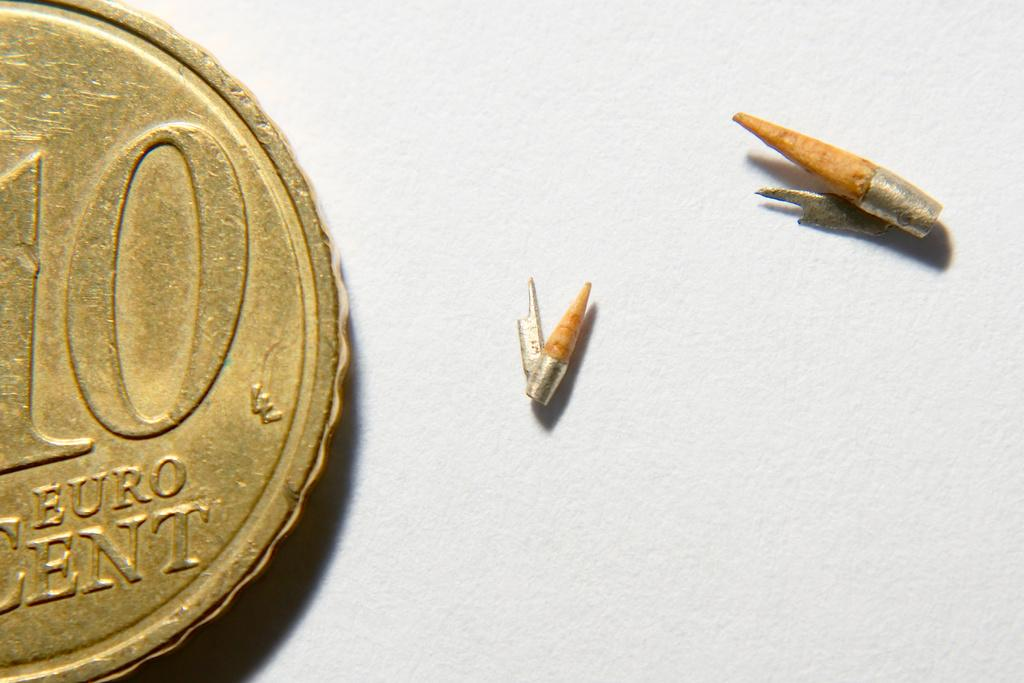What is located on the left side of the image? There is a coin on the left side of the image. What can be seen on the right side of the image? There are objects on the right side of the image. How many cakes are being steamed in the image? There are no cakes or steam present in the image. What type of card is visible in the image? There is no card visible in the image. 